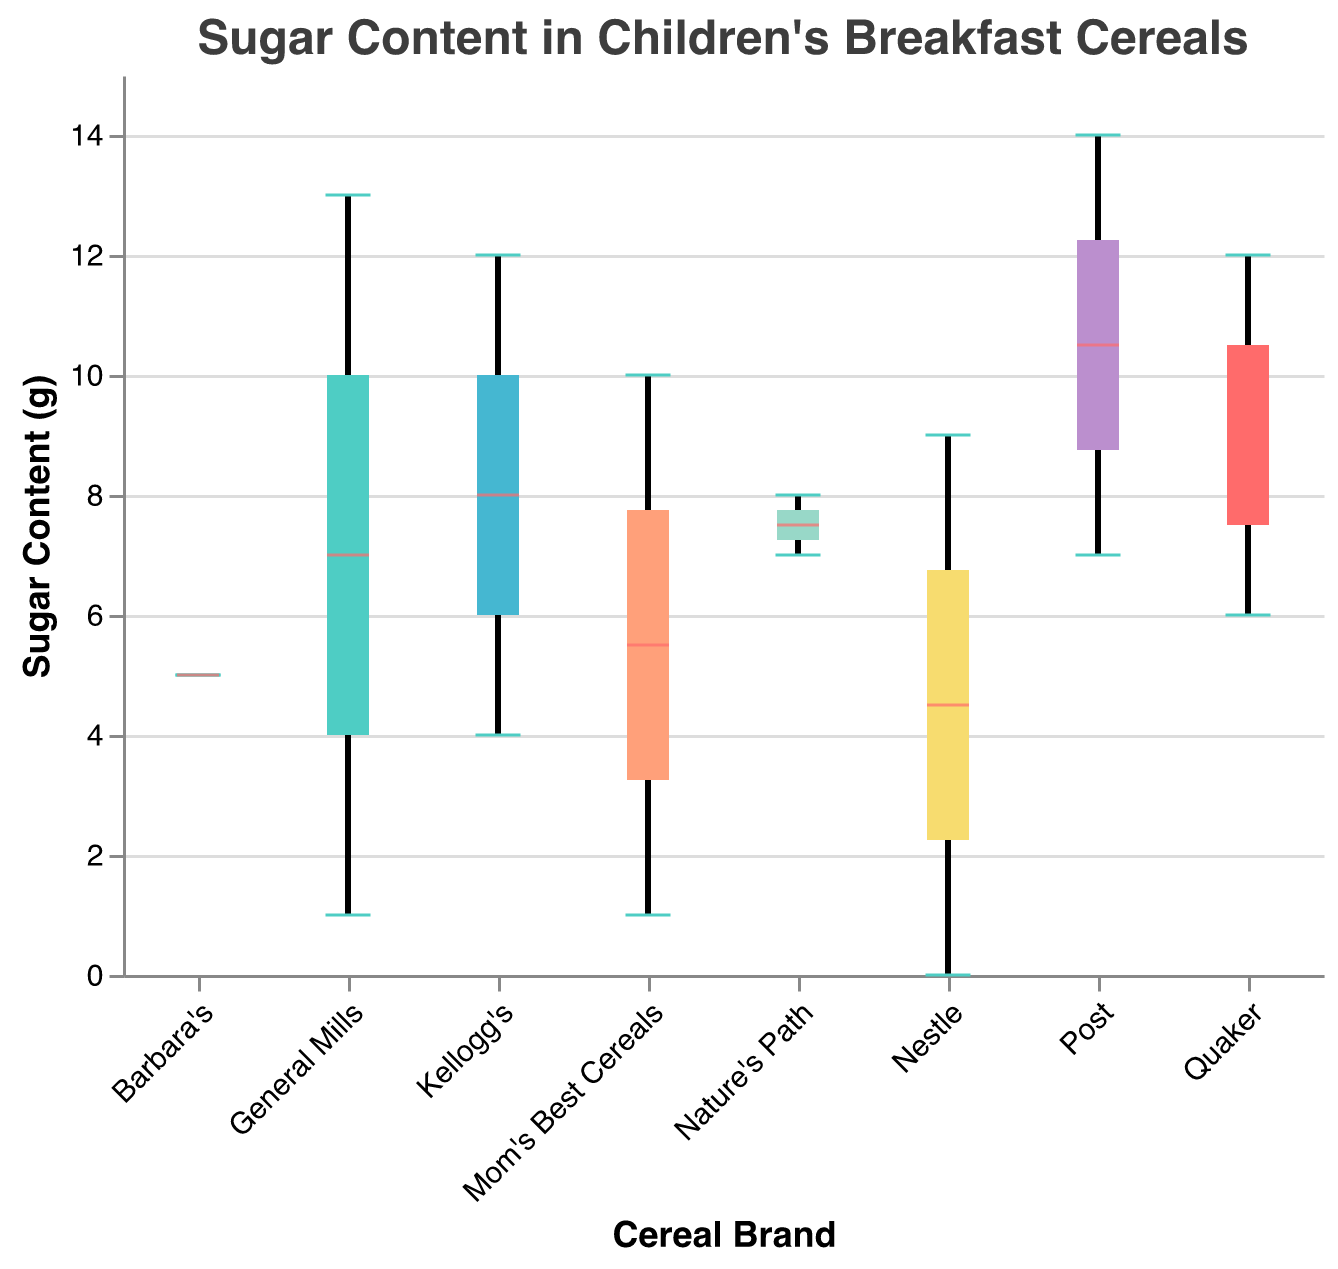what is the title of the figure? The title is usually located at the top of the figure and provides a brief description of what the figure is about. In this case, it is written in the coding details as "Sugar Content in Children's Breakfast Cereals".
Answer: Sugar Content in Children's Breakfast Cereals What is the maximum sugar content found in cereals from the brand "Post"? The maximum value in a box plot is shown by the top whisker or the highest point. For the brand "Post", the highest value is 14g, as indicated by their cereal "Golden Crisp".
Answer: 14g Which brand has the widest range of sugar content? The range (difference between the maximum and minimum) is visible by looking at the spread of the whiskers. "General Mills" shows a wide range as it has cereals with 1g and 13g of sugar.
Answer: General Mills Among "Kellogg's" cereals, which one has the lower sugar content and how much is it? "Rice Krispies" represents Kellogg's lowest sugar content which can be read directly from the data labeling.
Answer: Rice Krispies, 4g Which brand has the cereal with the least amount of sugar, and what is its content? The lowest point in the box plot corresponds to the cereal with the least sugar. "Nestle" has "Shredded Wheat" with 0g of sugar.
Answer: Nestle, 0g Which brand has the highest median sugar content? The median in a box plot is displayed as a horizontal line inside the box. Comparing all the medians, "Post" has the highest median sugar content.
Answer: Post How many brands have a cereal with exactly 12g of sugar content? By looking at the data points and referencing the box plot’s whiskers, "Kellogg's" (Frosted Flakes) and "Quaker" (Cap’n Crunch) show cereals with 12g of sugar.
Answer: Two brands What is the interquartile range (IQR) of sugar content for "Nature's Path"? The IQR can be calculated by subtracting the lower quartile (first quartile) from the upper (third quartile). The lower quartile is at 1g and the upper is at 7g. So, IQR is 7g-1g.
Answer: 6g Which brands contain cereals with exactly 1g of sugar content? Referencing the data points, "General Mills" (Cheerios) and "Mom's Best Cereals" (Quick Oats) show cereals with exactly 1g of sugar content.
Answer: General Mills, Mom's Best Cereals Which brand has the most variability in sugar content among its cereals? Variability is shown by both range and the spread of the interquartile range. "General Mills" shows the most spread, encompassing from 1g to 13g.
Answer: General Mills 